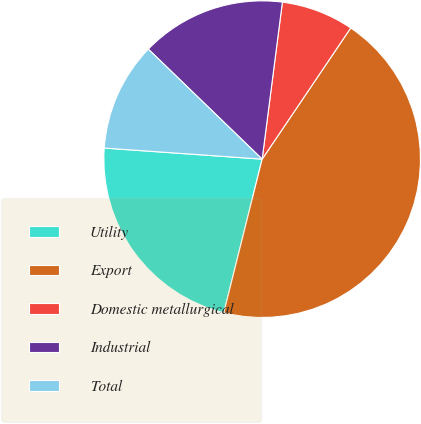<chart> <loc_0><loc_0><loc_500><loc_500><pie_chart><fcel>Utility<fcel>Export<fcel>Domestic metallurgical<fcel>Industrial<fcel>Total<nl><fcel>22.22%<fcel>44.44%<fcel>7.41%<fcel>14.81%<fcel>11.11%<nl></chart> 